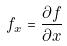<formula> <loc_0><loc_0><loc_500><loc_500>f _ { x } = \frac { \partial f } { \partial x }</formula> 